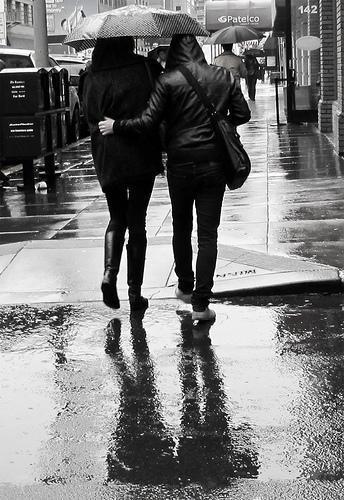How many people are there?
Give a very brief answer. 2. 